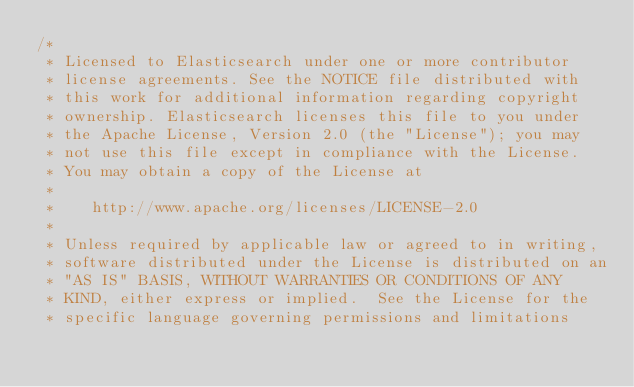Convert code to text. <code><loc_0><loc_0><loc_500><loc_500><_Java_>/*
 * Licensed to Elasticsearch under one or more contributor
 * license agreements. See the NOTICE file distributed with
 * this work for additional information regarding copyright
 * ownership. Elasticsearch licenses this file to you under
 * the Apache License, Version 2.0 (the "License"); you may
 * not use this file except in compliance with the License.
 * You may obtain a copy of the License at
 *
 *    http://www.apache.org/licenses/LICENSE-2.0
 *
 * Unless required by applicable law or agreed to in writing,
 * software distributed under the License is distributed on an
 * "AS IS" BASIS, WITHOUT WARRANTIES OR CONDITIONS OF ANY
 * KIND, either express or implied.  See the License for the
 * specific language governing permissions and limitations</code> 